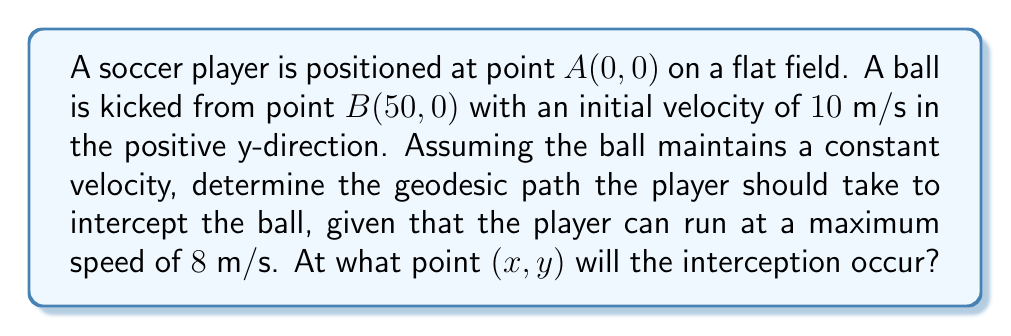Help me with this question. Let's approach this step-by-step:

1) First, we need to understand that on a flat field, the geodesic path (shortest path) between two points is a straight line.

2) The ball's position at time $t$ can be described by:
   $x_b = 50$
   $y_b = 10t$

3) The player's position at time $t$, assuming they run in a straight line at maximum speed, can be described by:
   $x_p = 8t \cos(\theta)$
   $y_p = 8t \sin(\theta)$
   where $\theta$ is the angle of the player's path with respect to the x-axis.

4) For interception, the player's position must equal the ball's position at some time $t$:
   $50 = 8t \cos(\theta)$
   $10t = 8t \sin(\theta)$

5) From the second equation:
   $\sin(\theta) = \frac{10}{8} = 1.25$

6) However, $\sin(\theta)$ cannot be greater than 1, which means the player cannot intercept the ball by running in a straight line at maximum speed.

7) The player needs to run to a point ahead of the ball's path and wait for the ball to reach them. The optimal strategy is to run perpendicular to the ball's path.

8) The time it takes the player to reach the ball's path:
   $t_p = \frac{50}{8} = 6.25$ seconds

9) In this time, the ball will have traveled:
   $y = 10 * 6.25 = 62.5$ meters

10) Therefore, the interception point is (50, 62.5).

[asy]
unitsize(2mm);
draw((0,0)--(100,0), arrow=Arrow(TeXHead));
draw((0,0)--(0,100), arrow=Arrow(TeXHead));
dot((0,0));
dot((50,0));
dot((50,62.5));
draw((0,0)--(50,62.5), red);
draw((50,0)--(50,62.5), blue, arrow=Arrow(TeXHead));
label("A(0,0)", (0,0), SW);
label("B(50,0)", (50,0), S);
label("(50,62.5)", (50,62.5), NE);
label("Player's path", (25,31), NW, red);
label("Ball's path", (52,31), E, blue);
[/asy]
Answer: (50, 62.5) 